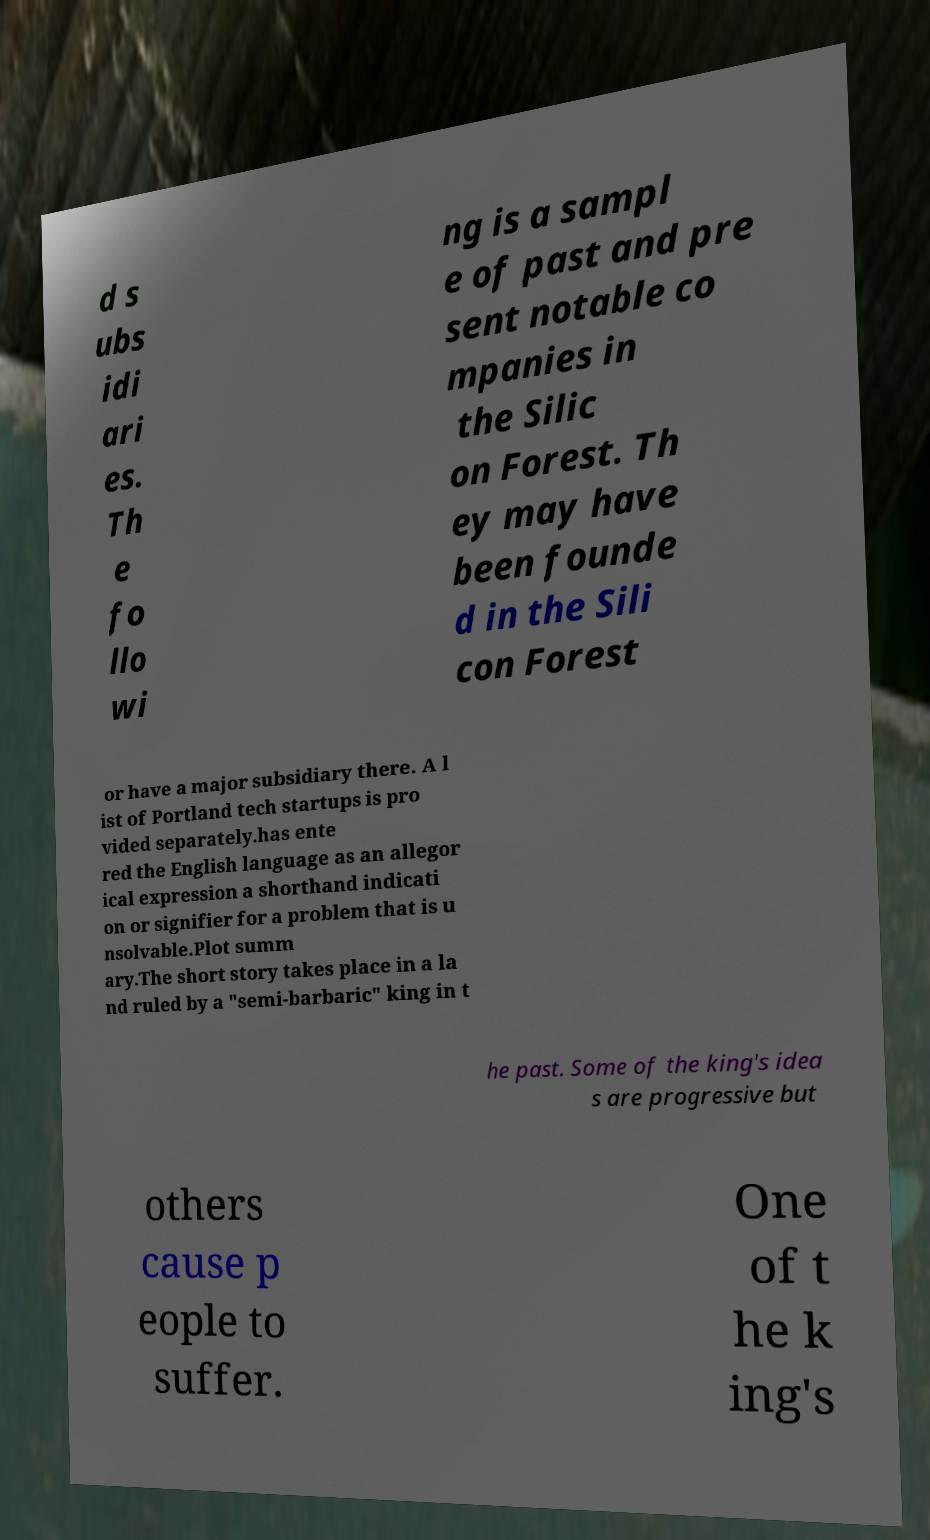Can you accurately transcribe the text from the provided image for me? d s ubs idi ari es. Th e fo llo wi ng is a sampl e of past and pre sent notable co mpanies in the Silic on Forest. Th ey may have been founde d in the Sili con Forest or have a major subsidiary there. A l ist of Portland tech startups is pro vided separately.has ente red the English language as an allegor ical expression a shorthand indicati on or signifier for a problem that is u nsolvable.Plot summ ary.The short story takes place in a la nd ruled by a "semi-barbaric" king in t he past. Some of the king's idea s are progressive but others cause p eople to suffer. One of t he k ing's 